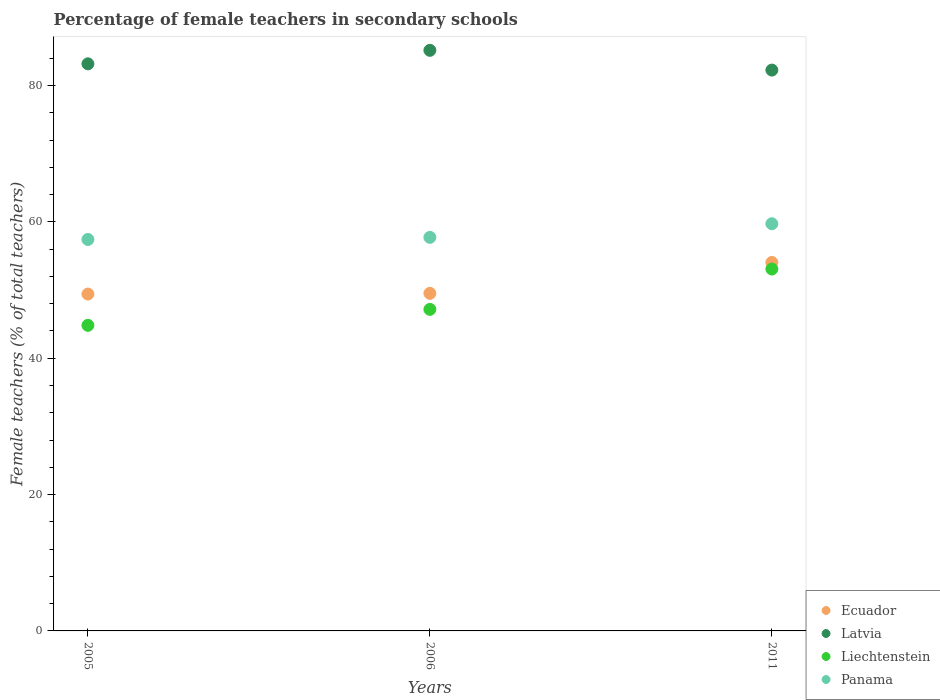Is the number of dotlines equal to the number of legend labels?
Provide a short and direct response. Yes. What is the percentage of female teachers in Ecuador in 2006?
Your response must be concise. 49.51. Across all years, what is the maximum percentage of female teachers in Ecuador?
Your response must be concise. 54.04. Across all years, what is the minimum percentage of female teachers in Latvia?
Offer a very short reply. 82.25. In which year was the percentage of female teachers in Ecuador maximum?
Give a very brief answer. 2011. What is the total percentage of female teachers in Latvia in the graph?
Give a very brief answer. 250.58. What is the difference between the percentage of female teachers in Ecuador in 2006 and that in 2011?
Provide a short and direct response. -4.53. What is the difference between the percentage of female teachers in Liechtenstein in 2006 and the percentage of female teachers in Panama in 2005?
Provide a succinct answer. -10.25. What is the average percentage of female teachers in Panama per year?
Provide a succinct answer. 58.28. In the year 2005, what is the difference between the percentage of female teachers in Liechtenstein and percentage of female teachers in Panama?
Your answer should be compact. -12.6. What is the ratio of the percentage of female teachers in Panama in 2005 to that in 2011?
Ensure brevity in your answer.  0.96. Is the difference between the percentage of female teachers in Liechtenstein in 2005 and 2006 greater than the difference between the percentage of female teachers in Panama in 2005 and 2006?
Make the answer very short. No. What is the difference between the highest and the second highest percentage of female teachers in Panama?
Your response must be concise. 2. What is the difference between the highest and the lowest percentage of female teachers in Ecuador?
Make the answer very short. 4.64. Is it the case that in every year, the sum of the percentage of female teachers in Latvia and percentage of female teachers in Liechtenstein  is greater than the sum of percentage of female teachers in Ecuador and percentage of female teachers in Panama?
Your response must be concise. Yes. Does the percentage of female teachers in Liechtenstein monotonically increase over the years?
Make the answer very short. Yes. How many dotlines are there?
Give a very brief answer. 4. How many years are there in the graph?
Keep it short and to the point. 3. Are the values on the major ticks of Y-axis written in scientific E-notation?
Provide a succinct answer. No. Does the graph contain any zero values?
Your answer should be compact. No. Does the graph contain grids?
Provide a succinct answer. No. Where does the legend appear in the graph?
Your answer should be compact. Bottom right. How many legend labels are there?
Make the answer very short. 4. How are the legend labels stacked?
Offer a very short reply. Vertical. What is the title of the graph?
Keep it short and to the point. Percentage of female teachers in secondary schools. What is the label or title of the X-axis?
Provide a succinct answer. Years. What is the label or title of the Y-axis?
Your answer should be compact. Female teachers (% of total teachers). What is the Female teachers (% of total teachers) in Ecuador in 2005?
Ensure brevity in your answer.  49.41. What is the Female teachers (% of total teachers) of Latvia in 2005?
Give a very brief answer. 83.17. What is the Female teachers (% of total teachers) in Liechtenstein in 2005?
Your response must be concise. 44.82. What is the Female teachers (% of total teachers) of Panama in 2005?
Offer a terse response. 57.41. What is the Female teachers (% of total teachers) of Ecuador in 2006?
Keep it short and to the point. 49.51. What is the Female teachers (% of total teachers) of Latvia in 2006?
Offer a terse response. 85.15. What is the Female teachers (% of total teachers) in Liechtenstein in 2006?
Make the answer very short. 47.16. What is the Female teachers (% of total teachers) of Panama in 2006?
Offer a very short reply. 57.72. What is the Female teachers (% of total teachers) in Ecuador in 2011?
Give a very brief answer. 54.04. What is the Female teachers (% of total teachers) of Latvia in 2011?
Ensure brevity in your answer.  82.25. What is the Female teachers (% of total teachers) of Liechtenstein in 2011?
Your response must be concise. 53.07. What is the Female teachers (% of total teachers) in Panama in 2011?
Your response must be concise. 59.72. Across all years, what is the maximum Female teachers (% of total teachers) in Ecuador?
Your answer should be compact. 54.04. Across all years, what is the maximum Female teachers (% of total teachers) of Latvia?
Ensure brevity in your answer.  85.15. Across all years, what is the maximum Female teachers (% of total teachers) in Liechtenstein?
Provide a succinct answer. 53.07. Across all years, what is the maximum Female teachers (% of total teachers) in Panama?
Provide a succinct answer. 59.72. Across all years, what is the minimum Female teachers (% of total teachers) in Ecuador?
Provide a short and direct response. 49.41. Across all years, what is the minimum Female teachers (% of total teachers) of Latvia?
Make the answer very short. 82.25. Across all years, what is the minimum Female teachers (% of total teachers) in Liechtenstein?
Make the answer very short. 44.82. Across all years, what is the minimum Female teachers (% of total teachers) in Panama?
Offer a very short reply. 57.41. What is the total Female teachers (% of total teachers) in Ecuador in the graph?
Offer a very short reply. 152.96. What is the total Female teachers (% of total teachers) in Latvia in the graph?
Offer a very short reply. 250.58. What is the total Female teachers (% of total teachers) of Liechtenstein in the graph?
Keep it short and to the point. 145.05. What is the total Female teachers (% of total teachers) in Panama in the graph?
Your answer should be very brief. 174.85. What is the difference between the Female teachers (% of total teachers) in Ecuador in 2005 and that in 2006?
Your answer should be very brief. -0.1. What is the difference between the Female teachers (% of total teachers) in Latvia in 2005 and that in 2006?
Your answer should be very brief. -1.98. What is the difference between the Female teachers (% of total teachers) in Liechtenstein in 2005 and that in 2006?
Make the answer very short. -2.34. What is the difference between the Female teachers (% of total teachers) of Panama in 2005 and that in 2006?
Your response must be concise. -0.31. What is the difference between the Female teachers (% of total teachers) of Ecuador in 2005 and that in 2011?
Your answer should be very brief. -4.64. What is the difference between the Female teachers (% of total teachers) in Latvia in 2005 and that in 2011?
Offer a very short reply. 0.92. What is the difference between the Female teachers (% of total teachers) of Liechtenstein in 2005 and that in 2011?
Ensure brevity in your answer.  -8.26. What is the difference between the Female teachers (% of total teachers) in Panama in 2005 and that in 2011?
Your answer should be compact. -2.31. What is the difference between the Female teachers (% of total teachers) of Ecuador in 2006 and that in 2011?
Keep it short and to the point. -4.53. What is the difference between the Female teachers (% of total teachers) in Latvia in 2006 and that in 2011?
Ensure brevity in your answer.  2.9. What is the difference between the Female teachers (% of total teachers) of Liechtenstein in 2006 and that in 2011?
Provide a succinct answer. -5.92. What is the difference between the Female teachers (% of total teachers) of Panama in 2006 and that in 2011?
Your response must be concise. -2. What is the difference between the Female teachers (% of total teachers) in Ecuador in 2005 and the Female teachers (% of total teachers) in Latvia in 2006?
Make the answer very short. -35.75. What is the difference between the Female teachers (% of total teachers) in Ecuador in 2005 and the Female teachers (% of total teachers) in Liechtenstein in 2006?
Your answer should be very brief. 2.25. What is the difference between the Female teachers (% of total teachers) of Ecuador in 2005 and the Female teachers (% of total teachers) of Panama in 2006?
Your response must be concise. -8.31. What is the difference between the Female teachers (% of total teachers) of Latvia in 2005 and the Female teachers (% of total teachers) of Liechtenstein in 2006?
Offer a very short reply. 36.01. What is the difference between the Female teachers (% of total teachers) in Latvia in 2005 and the Female teachers (% of total teachers) in Panama in 2006?
Your answer should be compact. 25.45. What is the difference between the Female teachers (% of total teachers) of Liechtenstein in 2005 and the Female teachers (% of total teachers) of Panama in 2006?
Your response must be concise. -12.9. What is the difference between the Female teachers (% of total teachers) of Ecuador in 2005 and the Female teachers (% of total teachers) of Latvia in 2011?
Make the answer very short. -32.85. What is the difference between the Female teachers (% of total teachers) of Ecuador in 2005 and the Female teachers (% of total teachers) of Liechtenstein in 2011?
Your answer should be very brief. -3.67. What is the difference between the Female teachers (% of total teachers) of Ecuador in 2005 and the Female teachers (% of total teachers) of Panama in 2011?
Offer a very short reply. -10.31. What is the difference between the Female teachers (% of total teachers) of Latvia in 2005 and the Female teachers (% of total teachers) of Liechtenstein in 2011?
Your answer should be very brief. 30.1. What is the difference between the Female teachers (% of total teachers) in Latvia in 2005 and the Female teachers (% of total teachers) in Panama in 2011?
Your response must be concise. 23.45. What is the difference between the Female teachers (% of total teachers) in Liechtenstein in 2005 and the Female teachers (% of total teachers) in Panama in 2011?
Your answer should be very brief. -14.9. What is the difference between the Female teachers (% of total teachers) in Ecuador in 2006 and the Female teachers (% of total teachers) in Latvia in 2011?
Make the answer very short. -32.74. What is the difference between the Female teachers (% of total teachers) in Ecuador in 2006 and the Female teachers (% of total teachers) in Liechtenstein in 2011?
Provide a succinct answer. -3.56. What is the difference between the Female teachers (% of total teachers) of Ecuador in 2006 and the Female teachers (% of total teachers) of Panama in 2011?
Offer a terse response. -10.21. What is the difference between the Female teachers (% of total teachers) of Latvia in 2006 and the Female teachers (% of total teachers) of Liechtenstein in 2011?
Provide a succinct answer. 32.08. What is the difference between the Female teachers (% of total teachers) of Latvia in 2006 and the Female teachers (% of total teachers) of Panama in 2011?
Provide a short and direct response. 25.43. What is the difference between the Female teachers (% of total teachers) in Liechtenstein in 2006 and the Female teachers (% of total teachers) in Panama in 2011?
Your response must be concise. -12.56. What is the average Female teachers (% of total teachers) in Ecuador per year?
Give a very brief answer. 50.99. What is the average Female teachers (% of total teachers) of Latvia per year?
Make the answer very short. 83.53. What is the average Female teachers (% of total teachers) in Liechtenstein per year?
Ensure brevity in your answer.  48.35. What is the average Female teachers (% of total teachers) of Panama per year?
Ensure brevity in your answer.  58.28. In the year 2005, what is the difference between the Female teachers (% of total teachers) of Ecuador and Female teachers (% of total teachers) of Latvia?
Give a very brief answer. -33.76. In the year 2005, what is the difference between the Female teachers (% of total teachers) in Ecuador and Female teachers (% of total teachers) in Liechtenstein?
Your answer should be very brief. 4.59. In the year 2005, what is the difference between the Female teachers (% of total teachers) in Ecuador and Female teachers (% of total teachers) in Panama?
Your answer should be compact. -8.01. In the year 2005, what is the difference between the Female teachers (% of total teachers) in Latvia and Female teachers (% of total teachers) in Liechtenstein?
Make the answer very short. 38.35. In the year 2005, what is the difference between the Female teachers (% of total teachers) of Latvia and Female teachers (% of total teachers) of Panama?
Make the answer very short. 25.76. In the year 2005, what is the difference between the Female teachers (% of total teachers) in Liechtenstein and Female teachers (% of total teachers) in Panama?
Your answer should be very brief. -12.6. In the year 2006, what is the difference between the Female teachers (% of total teachers) in Ecuador and Female teachers (% of total teachers) in Latvia?
Offer a very short reply. -35.64. In the year 2006, what is the difference between the Female teachers (% of total teachers) in Ecuador and Female teachers (% of total teachers) in Liechtenstein?
Provide a short and direct response. 2.35. In the year 2006, what is the difference between the Female teachers (% of total teachers) of Ecuador and Female teachers (% of total teachers) of Panama?
Provide a short and direct response. -8.21. In the year 2006, what is the difference between the Female teachers (% of total teachers) of Latvia and Female teachers (% of total teachers) of Liechtenstein?
Offer a very short reply. 37.99. In the year 2006, what is the difference between the Female teachers (% of total teachers) in Latvia and Female teachers (% of total teachers) in Panama?
Provide a short and direct response. 27.43. In the year 2006, what is the difference between the Female teachers (% of total teachers) in Liechtenstein and Female teachers (% of total teachers) in Panama?
Provide a succinct answer. -10.56. In the year 2011, what is the difference between the Female teachers (% of total teachers) of Ecuador and Female teachers (% of total teachers) of Latvia?
Provide a short and direct response. -28.21. In the year 2011, what is the difference between the Female teachers (% of total teachers) of Ecuador and Female teachers (% of total teachers) of Liechtenstein?
Your response must be concise. 0.97. In the year 2011, what is the difference between the Female teachers (% of total teachers) in Ecuador and Female teachers (% of total teachers) in Panama?
Keep it short and to the point. -5.67. In the year 2011, what is the difference between the Female teachers (% of total teachers) in Latvia and Female teachers (% of total teachers) in Liechtenstein?
Provide a short and direct response. 29.18. In the year 2011, what is the difference between the Female teachers (% of total teachers) in Latvia and Female teachers (% of total teachers) in Panama?
Keep it short and to the point. 22.53. In the year 2011, what is the difference between the Female teachers (% of total teachers) in Liechtenstein and Female teachers (% of total teachers) in Panama?
Offer a terse response. -6.64. What is the ratio of the Female teachers (% of total teachers) of Latvia in 2005 to that in 2006?
Provide a short and direct response. 0.98. What is the ratio of the Female teachers (% of total teachers) of Liechtenstein in 2005 to that in 2006?
Your answer should be very brief. 0.95. What is the ratio of the Female teachers (% of total teachers) in Panama in 2005 to that in 2006?
Offer a very short reply. 0.99. What is the ratio of the Female teachers (% of total teachers) of Ecuador in 2005 to that in 2011?
Provide a short and direct response. 0.91. What is the ratio of the Female teachers (% of total teachers) of Latvia in 2005 to that in 2011?
Ensure brevity in your answer.  1.01. What is the ratio of the Female teachers (% of total teachers) of Liechtenstein in 2005 to that in 2011?
Your response must be concise. 0.84. What is the ratio of the Female teachers (% of total teachers) in Panama in 2005 to that in 2011?
Provide a succinct answer. 0.96. What is the ratio of the Female teachers (% of total teachers) of Ecuador in 2006 to that in 2011?
Your answer should be very brief. 0.92. What is the ratio of the Female teachers (% of total teachers) in Latvia in 2006 to that in 2011?
Offer a very short reply. 1.04. What is the ratio of the Female teachers (% of total teachers) of Liechtenstein in 2006 to that in 2011?
Offer a very short reply. 0.89. What is the ratio of the Female teachers (% of total teachers) in Panama in 2006 to that in 2011?
Provide a short and direct response. 0.97. What is the difference between the highest and the second highest Female teachers (% of total teachers) of Ecuador?
Offer a terse response. 4.53. What is the difference between the highest and the second highest Female teachers (% of total teachers) of Latvia?
Offer a terse response. 1.98. What is the difference between the highest and the second highest Female teachers (% of total teachers) in Liechtenstein?
Provide a short and direct response. 5.92. What is the difference between the highest and the second highest Female teachers (% of total teachers) in Panama?
Offer a very short reply. 2. What is the difference between the highest and the lowest Female teachers (% of total teachers) of Ecuador?
Offer a very short reply. 4.64. What is the difference between the highest and the lowest Female teachers (% of total teachers) in Latvia?
Offer a very short reply. 2.9. What is the difference between the highest and the lowest Female teachers (% of total teachers) in Liechtenstein?
Give a very brief answer. 8.26. What is the difference between the highest and the lowest Female teachers (% of total teachers) of Panama?
Give a very brief answer. 2.31. 